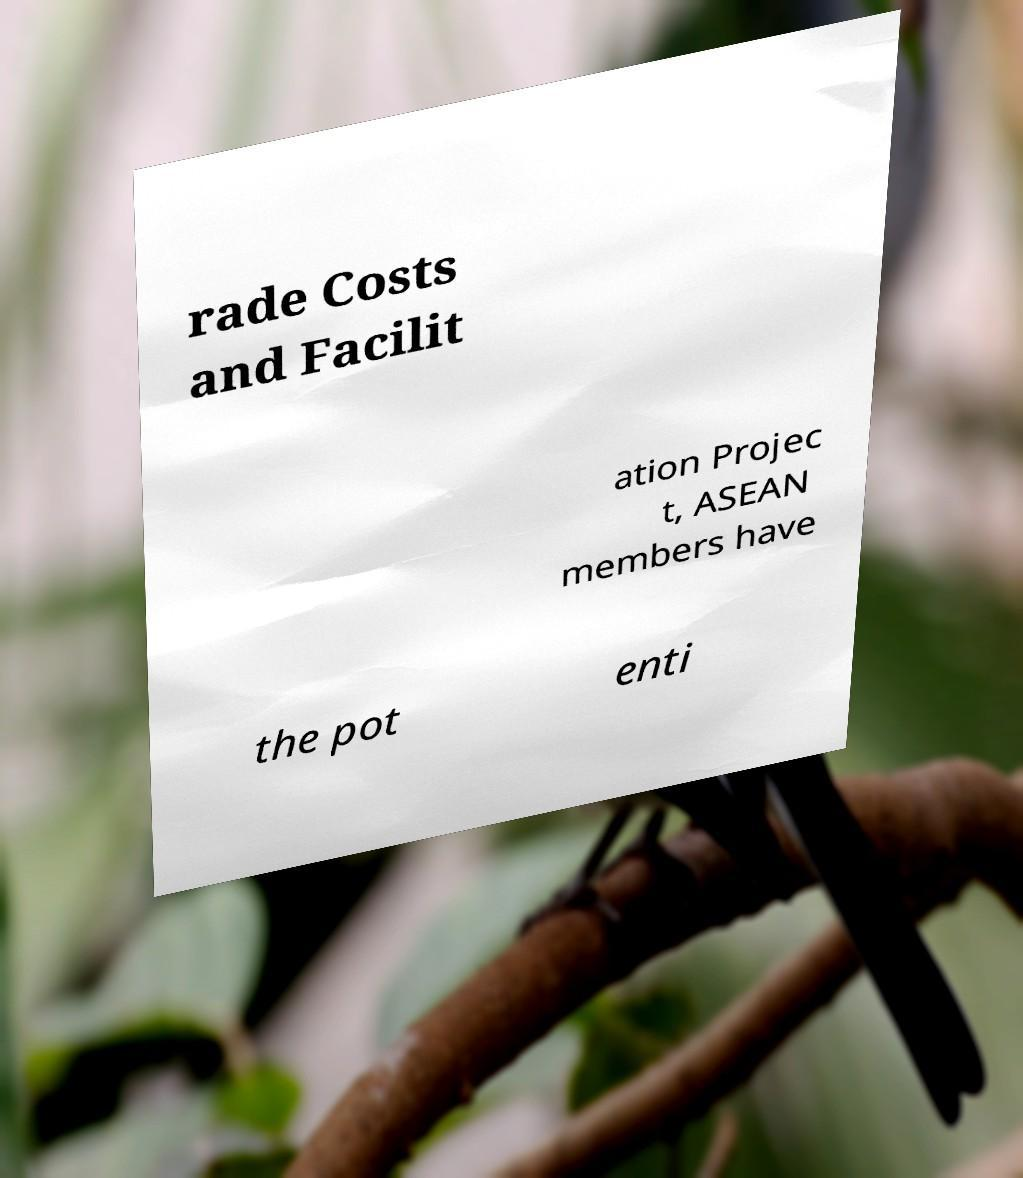Can you accurately transcribe the text from the provided image for me? rade Costs and Facilit ation Projec t, ASEAN members have the pot enti 